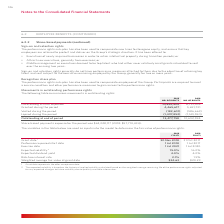According to Woolworths Limited's financial document, What was the share-based payments expense in 2018? According to the financial document, $57,710,434. The relevant text states: "ents expense for the period was $62,028,117 (2018: $57,710,434)...." Also, What is the Grant date in 2019? According to the financial document, 30 Nov 2018. The relevant text states: "Grant date 1 30 Nov 2018 31 Oct 2017 Performance period start date 1 Jul 2018 1 Jul 2017 Exercise date 1 Jul 2021 1 Jul 2020..." Also, What is the exercise date in 2018? According to the financial document, 1 Jul 2020. The relevant text states: "te 1 Jul 2018 1 Jul 2017 Exercise date 1 Jul 2021 1 Jul 2020 Expected volatility 2 15.0% 16.0% Expected dividend yield 4.0% 4.0% Risk-free interest rate 2.1% 1...." Also, can you calculate: What is the change in expected volatility between 2018 and 2019? Based on the calculation: 16.0% - 15.0% , the result is 1 (percentage). This is based on the information: "1 Jul 2021 1 Jul 2020 Expected volatility 2 15.0% 16.0% Expected dividend yield 4.0% 4.0% Risk-free interest rate 2.1% 1.9% Weighted average fair value at date 1 Jul 2021 1 Jul 2020 Expected volatilit..." The key data points involved are: 15.0, 16.0. Also, can you calculate: What is the average risk-free interest rate for 2018 and 2019? To answer this question, I need to perform calculations using the financial data. The calculation is: (2.1% + 1.9%)/2 , which equals 2 (percentage). This is based on the information: "dividend yield 4.0% 4.0% Risk-free interest rate 2.1% 1.9% Weighted average fair value at grant date $24.63 $20.23 dend yield 4.0% 4.0% Risk-free interest rate 2.1% 1.9% Weighted average fair value at..." The key data points involved are: 1.9, 2.1. Also, can you calculate: What is the change in expected dividend yield between 2018 and 2019? I cannot find a specific answer to this question in the financial document. 